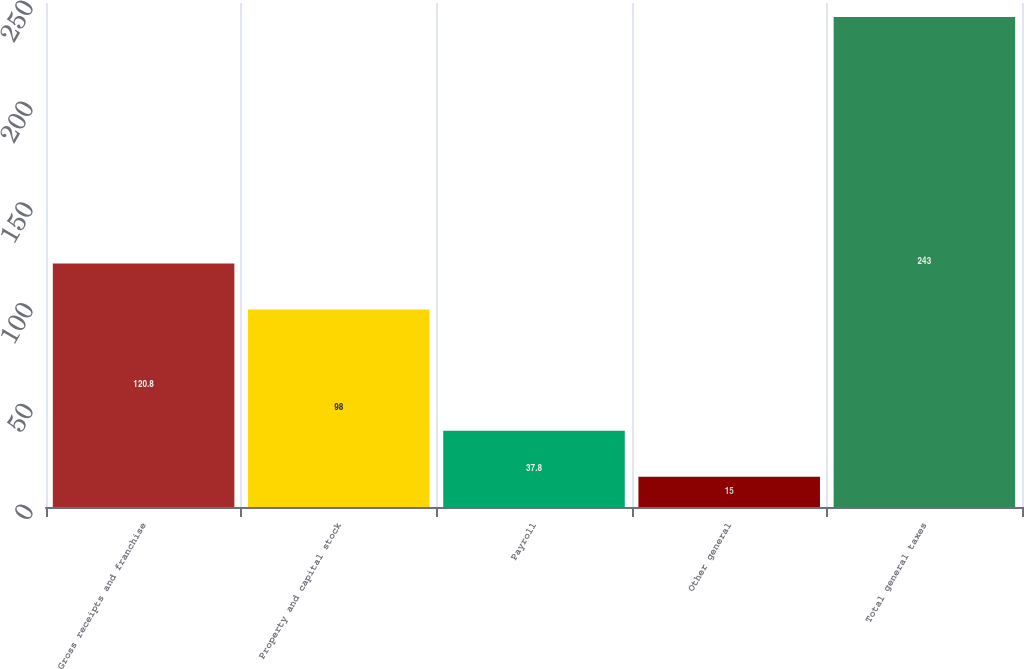Convert chart. <chart><loc_0><loc_0><loc_500><loc_500><bar_chart><fcel>Gross receipts and franchise<fcel>Property and capital stock<fcel>Payroll<fcel>Other general<fcel>Total general taxes<nl><fcel>120.8<fcel>98<fcel>37.8<fcel>15<fcel>243<nl></chart> 